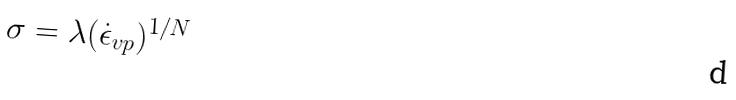<formula> <loc_0><loc_0><loc_500><loc_500>\sigma = \lambda ( \dot { \epsilon } _ { v p } ) ^ { 1 / N }</formula> 